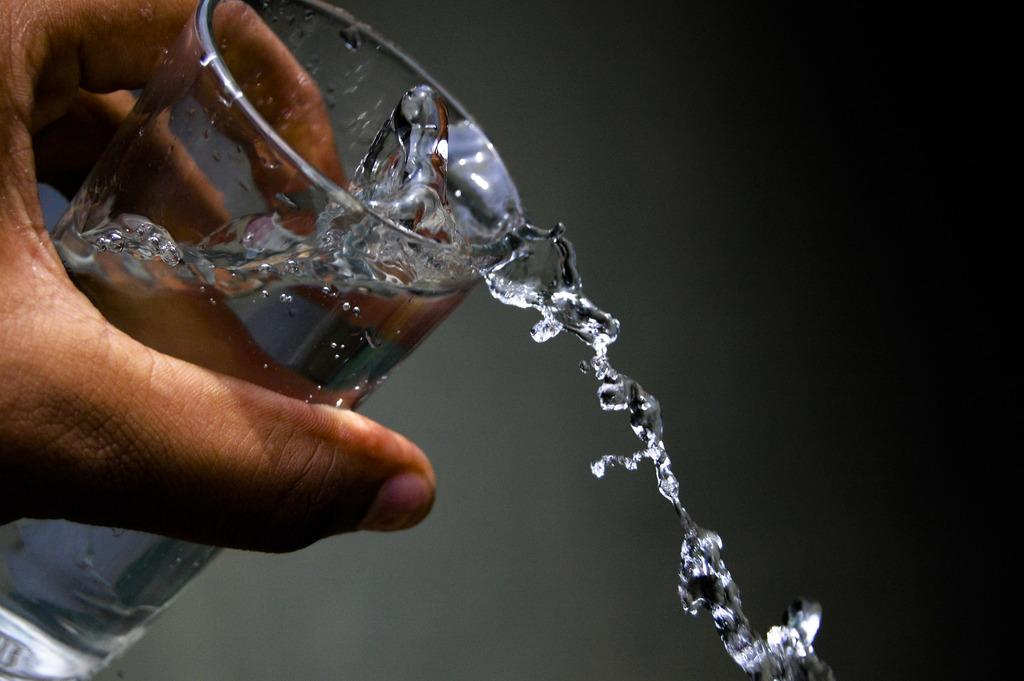What can be seen in the image related to a person's hand? There is a person's hand in the image. What is the hand holding? The hand is holding a glass of water. What is happening with the water in the glass? Water is falling from the glass. What is the person's belief about the ocean in the image? There is no mention of the ocean or any beliefs in the image. 